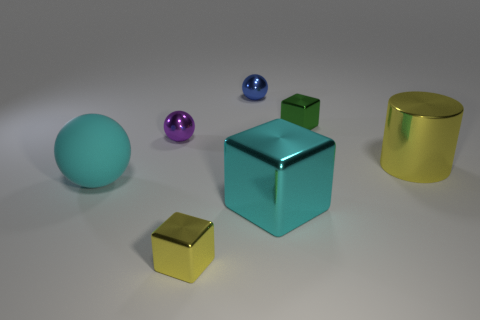There is a big metallic thing that is in front of the metallic cylinder; is it the same shape as the big yellow object?
Your answer should be compact. No. The other sphere that is made of the same material as the purple ball is what color?
Give a very brief answer. Blue. What number of yellow things are made of the same material as the large cube?
Offer a very short reply. 2. There is a small shiny block that is in front of the block behind the big rubber sphere that is in front of the purple object; what color is it?
Give a very brief answer. Yellow. Does the purple shiny sphere have the same size as the yellow cube?
Offer a terse response. Yes. Is there anything else that is the same shape as the cyan metallic object?
Give a very brief answer. Yes. What number of objects are shiny blocks to the right of the big metallic block or tiny blue matte spheres?
Offer a terse response. 1. Is the shape of the big yellow metallic object the same as the cyan shiny object?
Offer a terse response. No. How many other objects are there of the same size as the blue metallic object?
Ensure brevity in your answer.  3. The large metal cylinder is what color?
Your response must be concise. Yellow. 